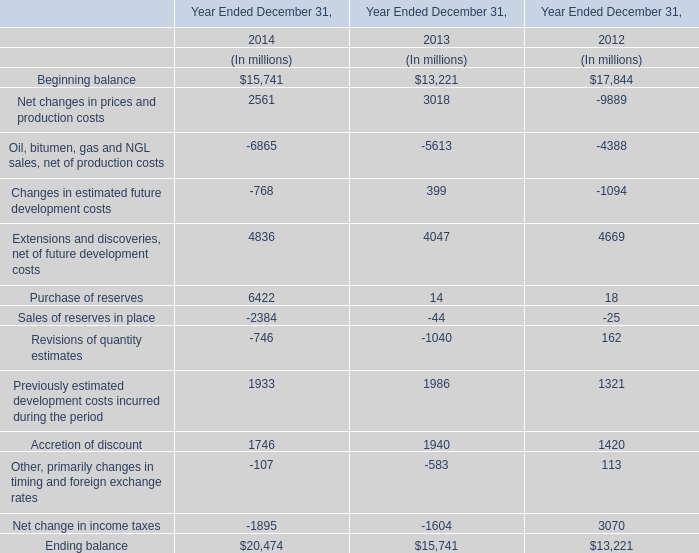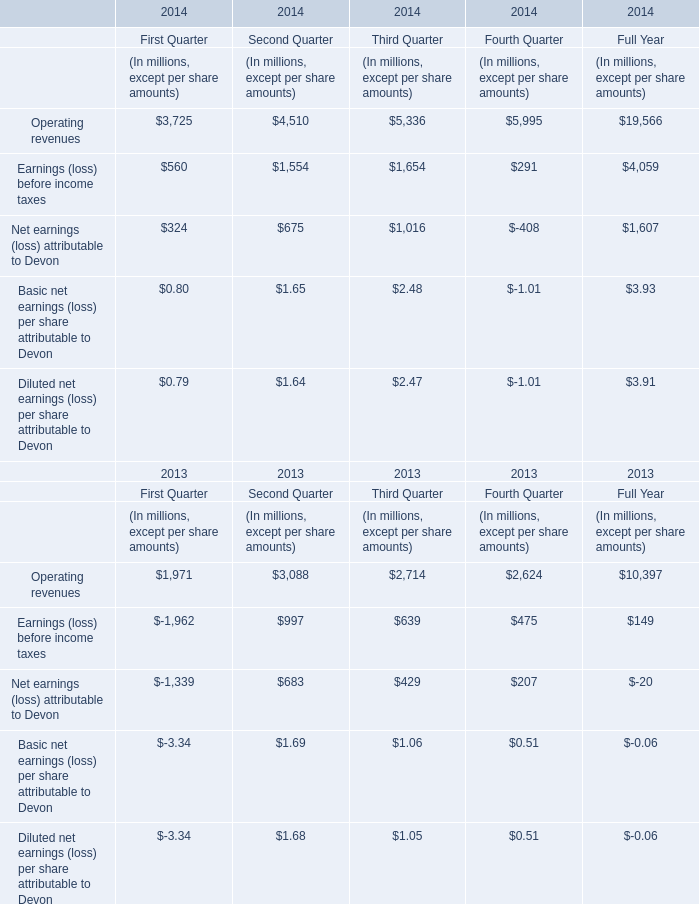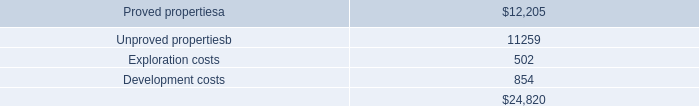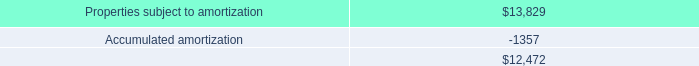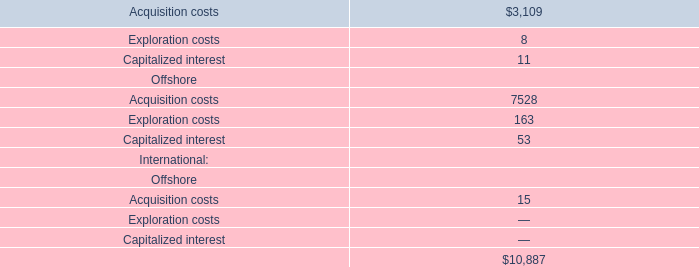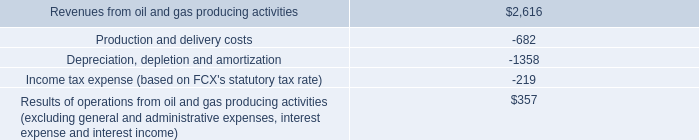What's the increasing rate of opening revenues in 2014? (in %) 
Computations: ((19566 - 10397) / 10397)
Answer: 0.88189. 